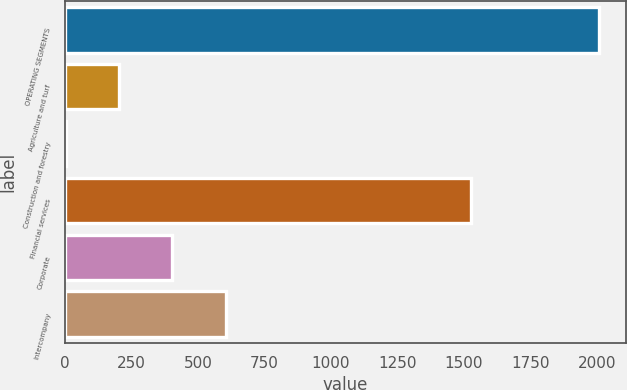<chart> <loc_0><loc_0><loc_500><loc_500><bar_chart><fcel>OPERATING SEGMENTS<fcel>Agriculture and turf<fcel>Construction and forestry<fcel>Financial services<fcel>Corporate<fcel>Intercompany<nl><fcel>2010<fcel>203.7<fcel>3<fcel>1528<fcel>404.4<fcel>605.1<nl></chart> 